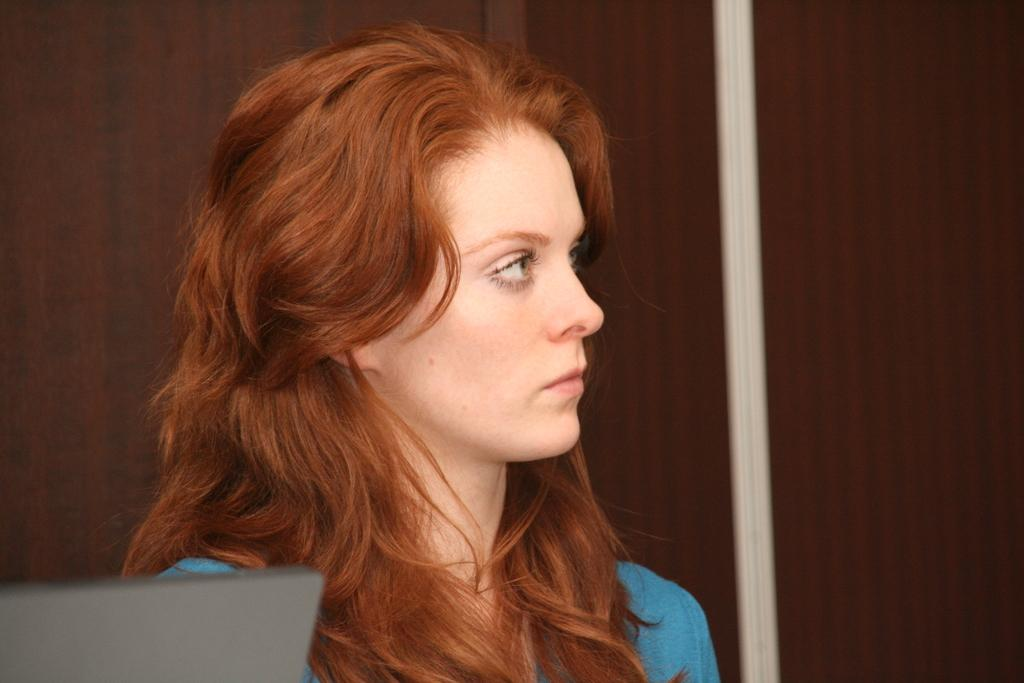Who is present in the image? There is a woman in the image. What is located beside the woman? There is an object beside the woman. What type of furniture is visible behind the woman? There is a wooden cupboard behind the woman. How many ants are crawling on the woman's arm in the image? There are no ants present in the image. 